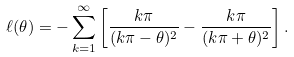<formula> <loc_0><loc_0><loc_500><loc_500>\ell ( \theta ) = - \sum _ { k = 1 } ^ { \infty } \left [ \frac { k \pi } { ( k \pi - \theta ) ^ { 2 } } - \frac { k \pi } { ( k \pi + \theta ) ^ { 2 } } \right ] .</formula> 